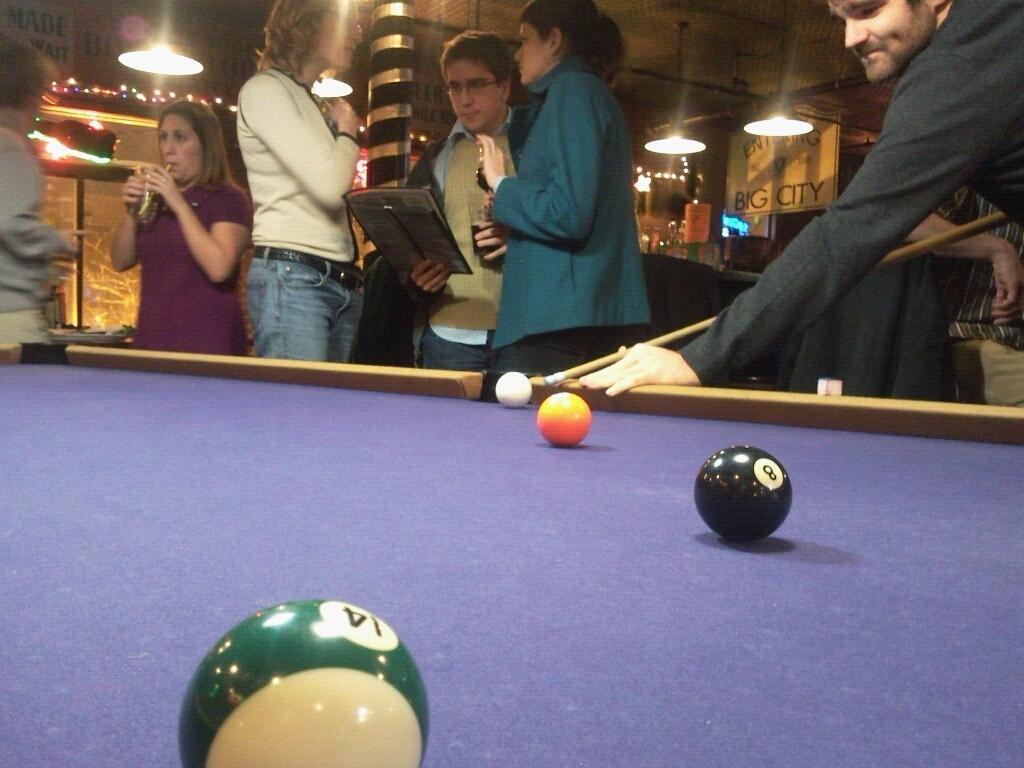In one or two sentences, can you explain what this image depicts? In this image I can see there are group of people who are standing on the floor and also a snooker table which has couple of balls on it. 